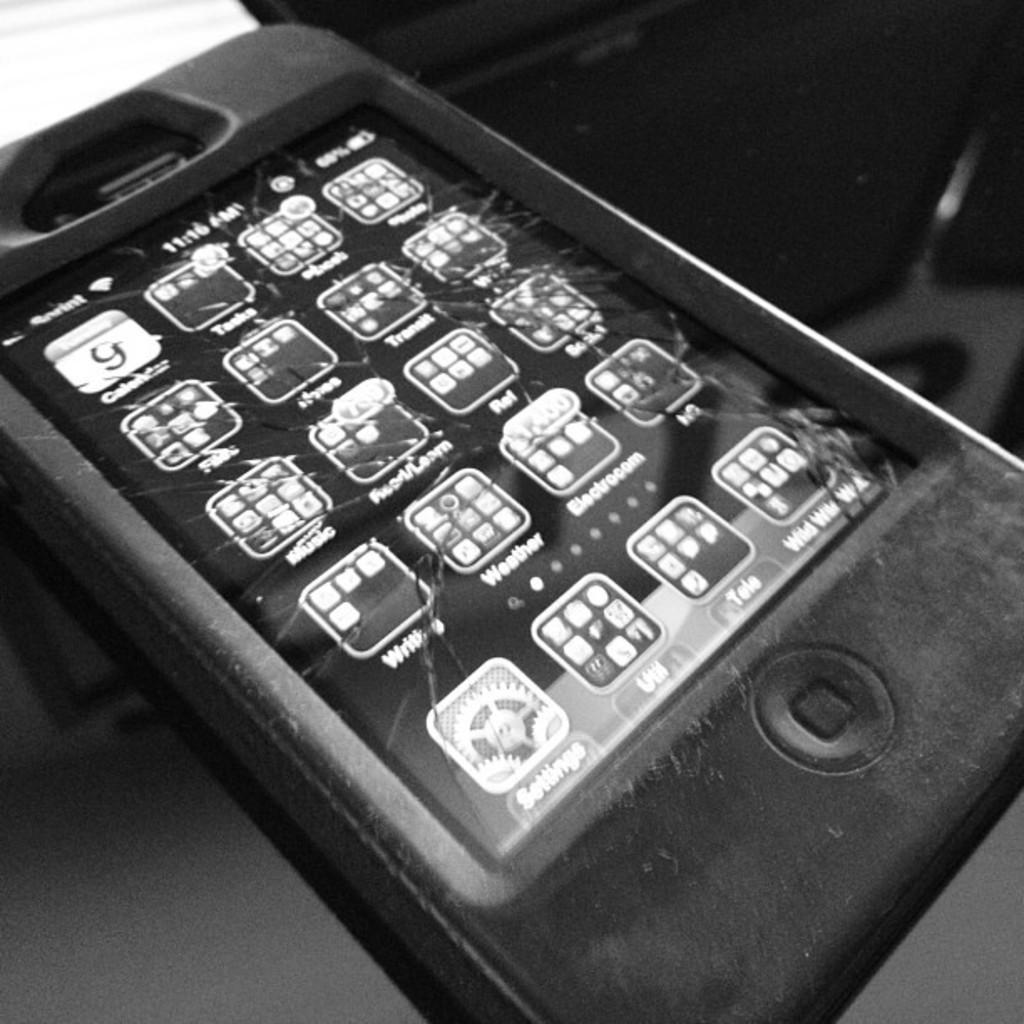Describe this image in one or two sentences. It is a black and white image. In this image there is a mobile with logos and apps. Beside the mobile there is some object. 